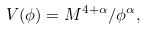<formula> <loc_0><loc_0><loc_500><loc_500>V ( \phi ) = { M ^ { 4 + \alpha } } / { \phi ^ { \alpha } } ,</formula> 